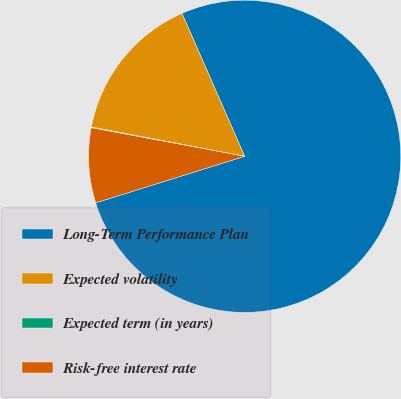<chart> <loc_0><loc_0><loc_500><loc_500><pie_chart><fcel>Long-Term Performance Plan<fcel>Expected volatility<fcel>Expected term (in years)<fcel>Risk-free interest rate<nl><fcel>76.76%<fcel>15.41%<fcel>0.08%<fcel>7.75%<nl></chart> 